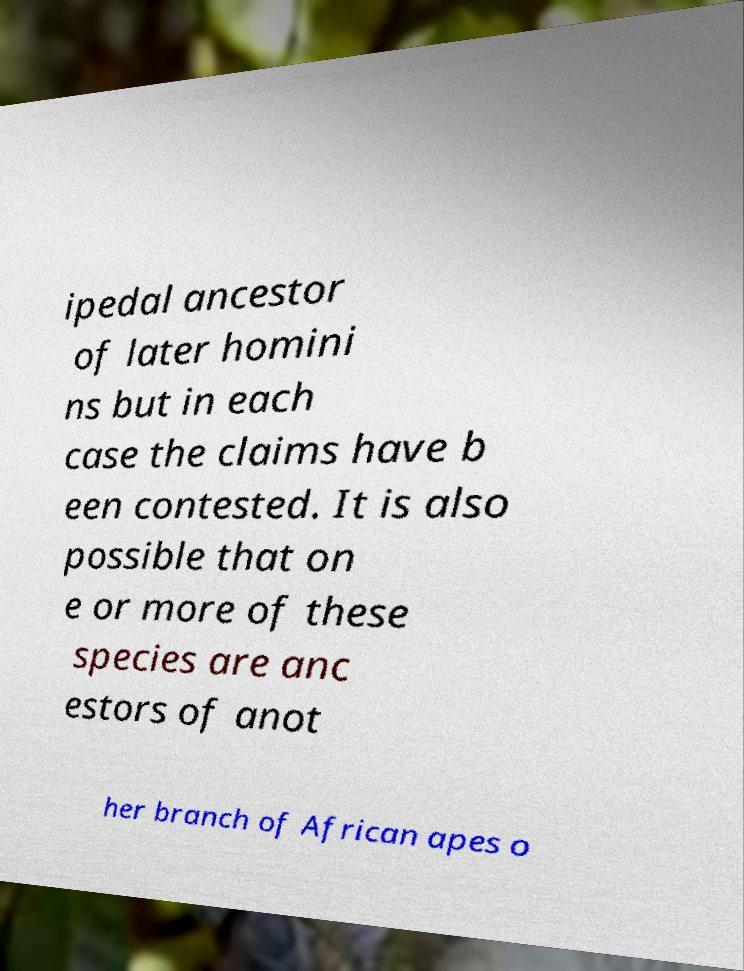Please read and relay the text visible in this image. What does it say? ipedal ancestor of later homini ns but in each case the claims have b een contested. It is also possible that on e or more of these species are anc estors of anot her branch of African apes o 